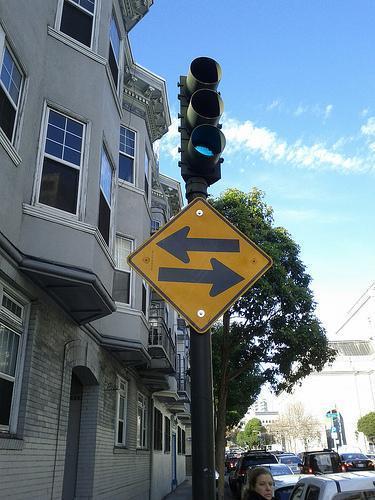How many arrows on the sign?
Give a very brief answer. 2. 